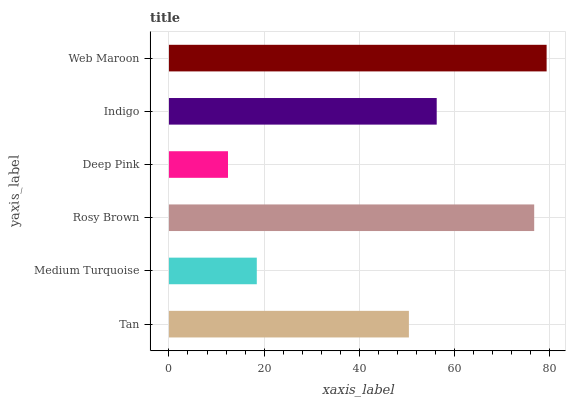Is Deep Pink the minimum?
Answer yes or no. Yes. Is Web Maroon the maximum?
Answer yes or no. Yes. Is Medium Turquoise the minimum?
Answer yes or no. No. Is Medium Turquoise the maximum?
Answer yes or no. No. Is Tan greater than Medium Turquoise?
Answer yes or no. Yes. Is Medium Turquoise less than Tan?
Answer yes or no. Yes. Is Medium Turquoise greater than Tan?
Answer yes or no. No. Is Tan less than Medium Turquoise?
Answer yes or no. No. Is Indigo the high median?
Answer yes or no. Yes. Is Tan the low median?
Answer yes or no. Yes. Is Medium Turquoise the high median?
Answer yes or no. No. Is Indigo the low median?
Answer yes or no. No. 